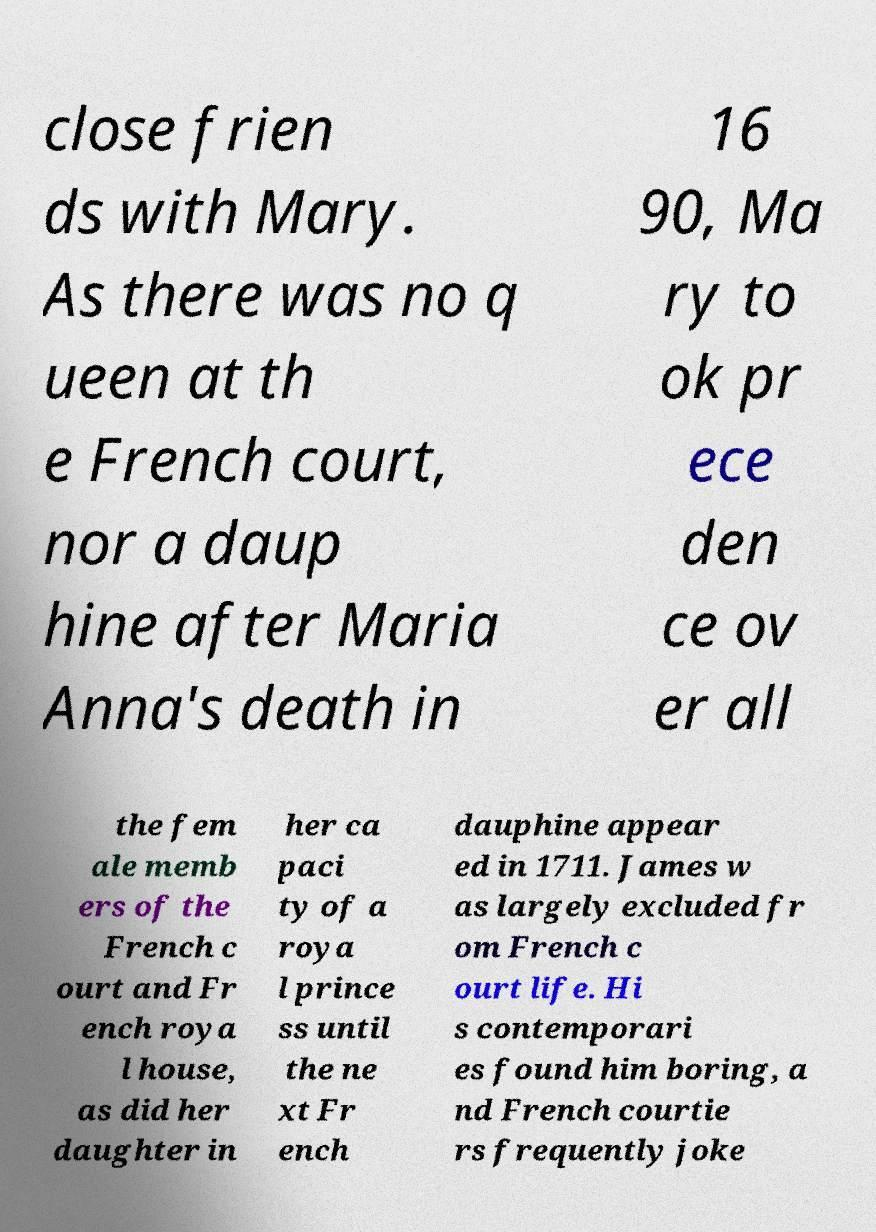There's text embedded in this image that I need extracted. Can you transcribe it verbatim? close frien ds with Mary. As there was no q ueen at th e French court, nor a daup hine after Maria Anna's death in 16 90, Ma ry to ok pr ece den ce ov er all the fem ale memb ers of the French c ourt and Fr ench roya l house, as did her daughter in her ca paci ty of a roya l prince ss until the ne xt Fr ench dauphine appear ed in 1711. James w as largely excluded fr om French c ourt life. Hi s contemporari es found him boring, a nd French courtie rs frequently joke 